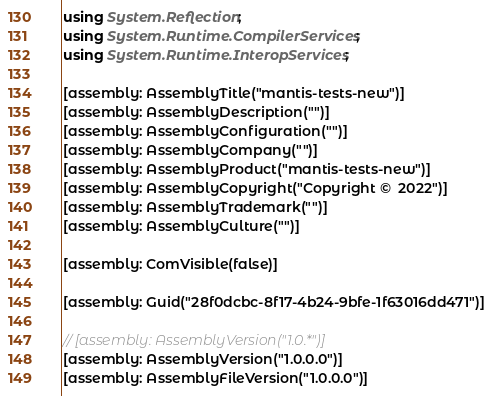Convert code to text. <code><loc_0><loc_0><loc_500><loc_500><_C#_>using System.Reflection;
using System.Runtime.CompilerServices;
using System.Runtime.InteropServices;

[assembly: AssemblyTitle("mantis-tests-new")]
[assembly: AssemblyDescription("")]
[assembly: AssemblyConfiguration("")]
[assembly: AssemblyCompany("")]
[assembly: AssemblyProduct("mantis-tests-new")]
[assembly: AssemblyCopyright("Copyright ©  2022")]
[assembly: AssemblyTrademark("")]
[assembly: AssemblyCulture("")]

[assembly: ComVisible(false)]

[assembly: Guid("28f0dcbc-8f17-4b24-9bfe-1f63016dd471")]

// [assembly: AssemblyVersion("1.0.*")]
[assembly: AssemblyVersion("1.0.0.0")]
[assembly: AssemblyFileVersion("1.0.0.0")]
</code> 